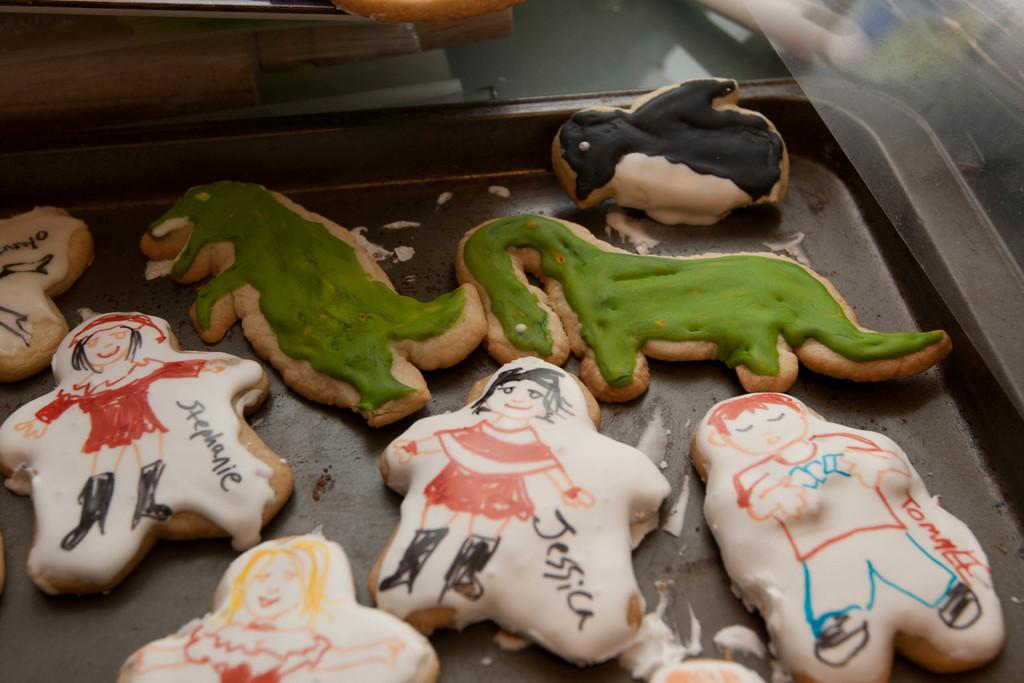What is located in the foreground of the picture? There is a tray in the foreground of the picture. What is on the tray? The tray contains cookies with different shapes. What utensils can be seen at the top of the image? There are knives visible at the top of the image. What other objects are present at the top of the image? There are additional objects present at the top of the image, but their specific details are not mentioned in the provided facts. What type of seed can be seen growing in the image? There is no seed or indication of plant growth present in the image. 